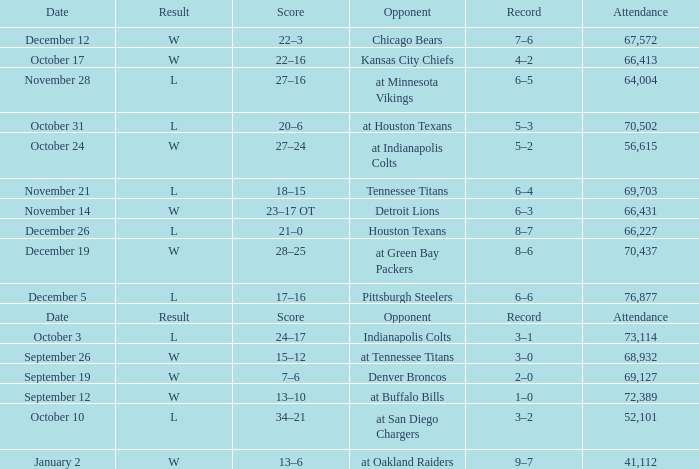What record has w as the result, with January 2 as the date? 9–7. 